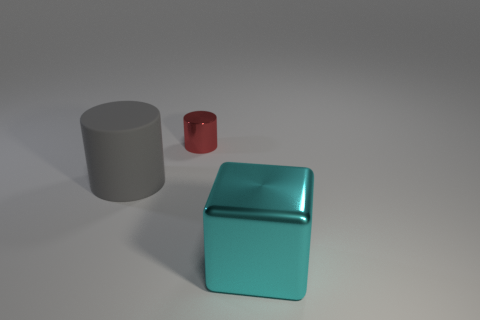Add 1 big gray cylinders. How many objects exist? 4 Subtract all blocks. How many objects are left? 2 Subtract all big gray things. Subtract all cyan shiny objects. How many objects are left? 1 Add 1 big cyan objects. How many big cyan objects are left? 2 Add 2 blocks. How many blocks exist? 3 Subtract 0 cyan cylinders. How many objects are left? 3 